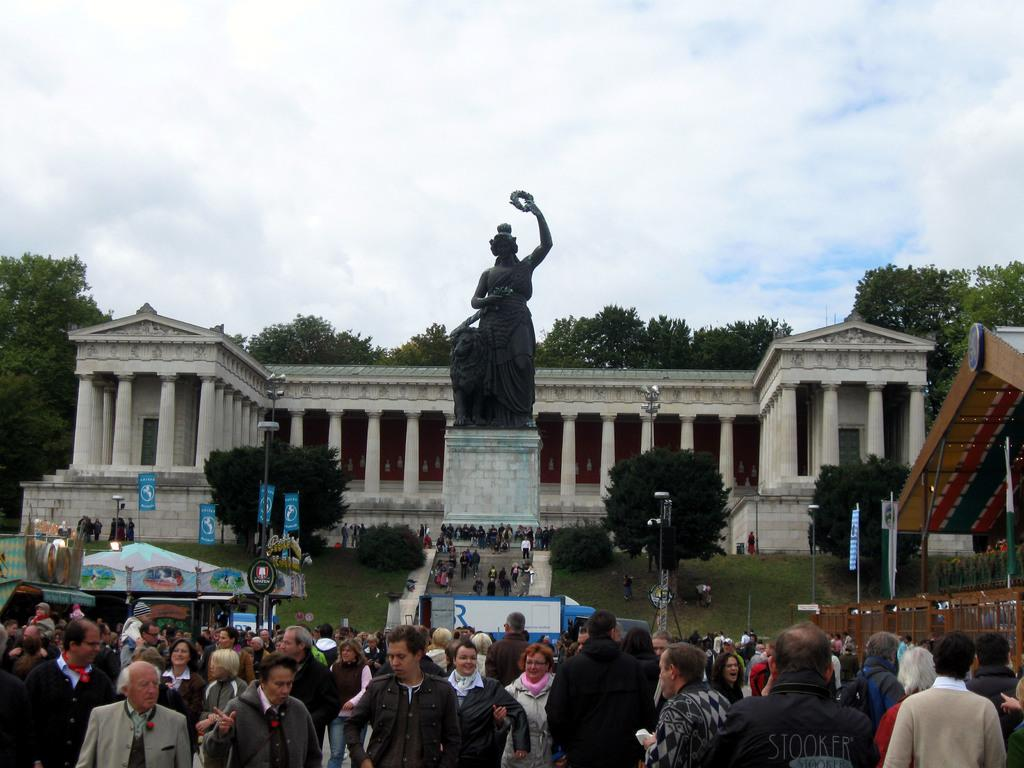What type of location is depicted in the image? The image depicts an historical place. What architectural features can be seen in the image? There are pillars in the image. What type of artwork is present in the image? There is a sculpture in the image. What type of vegetation is present in the image? There are plants, trees, and grass in the image. What type of structure is present in the image? There is a shed in the image. What type of establishment is present in the image? There is a store in the image. What type of decorations are present in the image? There are flags in the image. What type of lighting is present in the image? There are light poles in the image. Are there any people present in the image? Yes, there are people in the image. What is visible in the background of the image? Trees are visible in the background of the image. What is the weather like in the image? The sky is cloudy in the image. What type of furniture can be seen in the image? There is no furniture present in the image. 